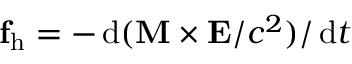Convert formula to latex. <formula><loc_0><loc_0><loc_500><loc_500>\mathbf f _ { h } = - \, d ( \mathbf M \times \mathbf E / c ^ { 2 } ) / \, d t</formula> 